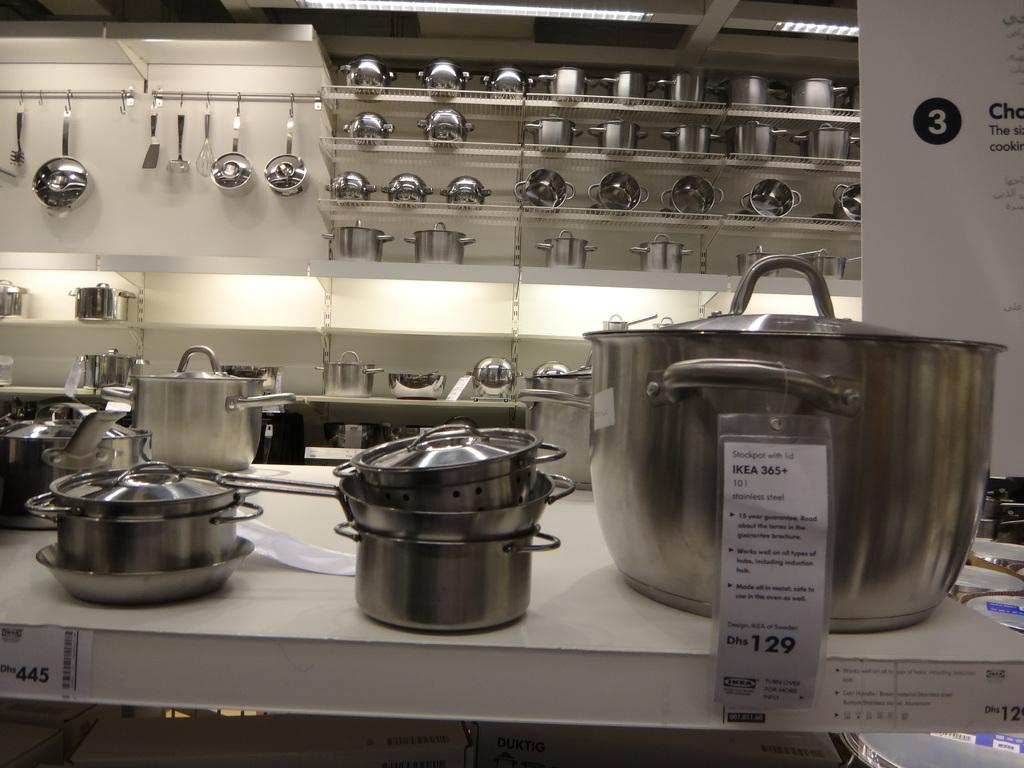<image>
Create a compact narrative representing the image presented. The new pots and pans are on display for sale at Ikea. 